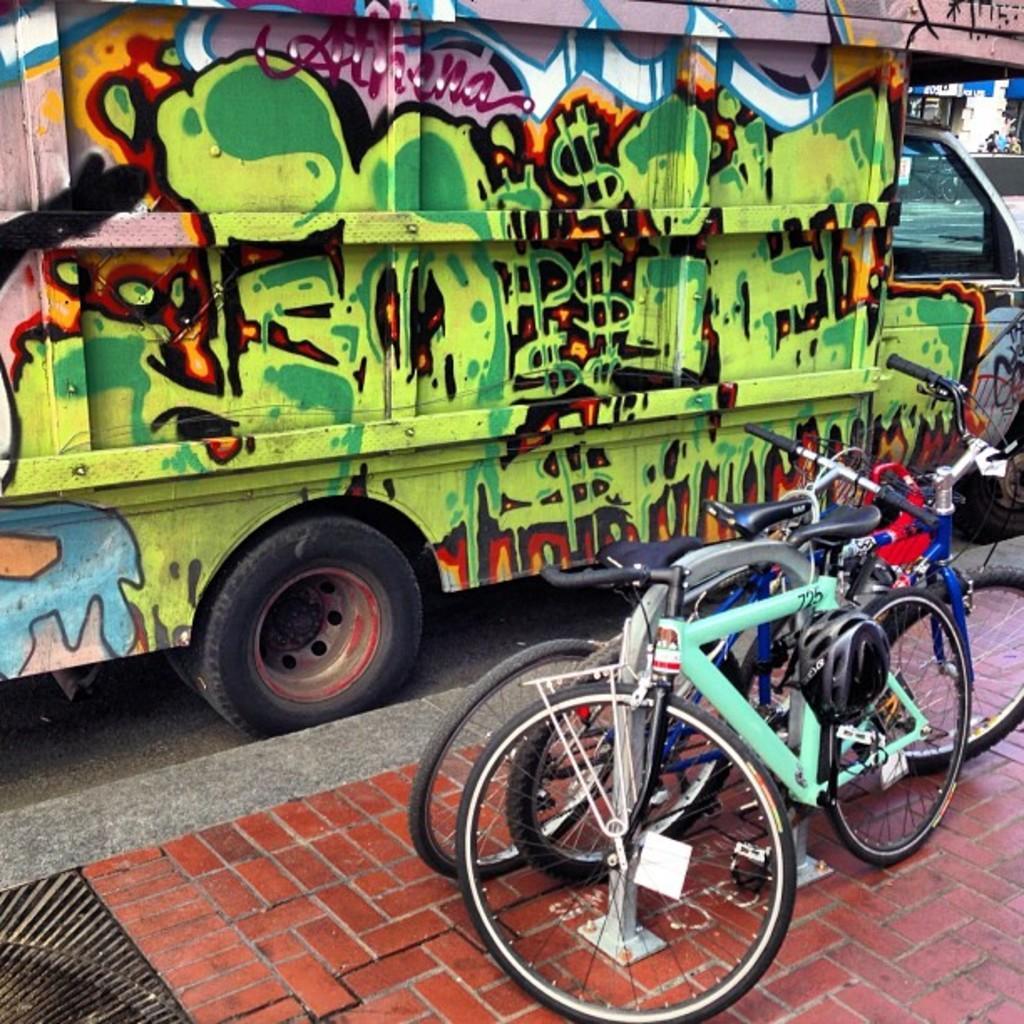Please provide a concise description of this image. In this picture we can see bicycles and a vehicle on the ground, helmets and in the background we can see some objects. 